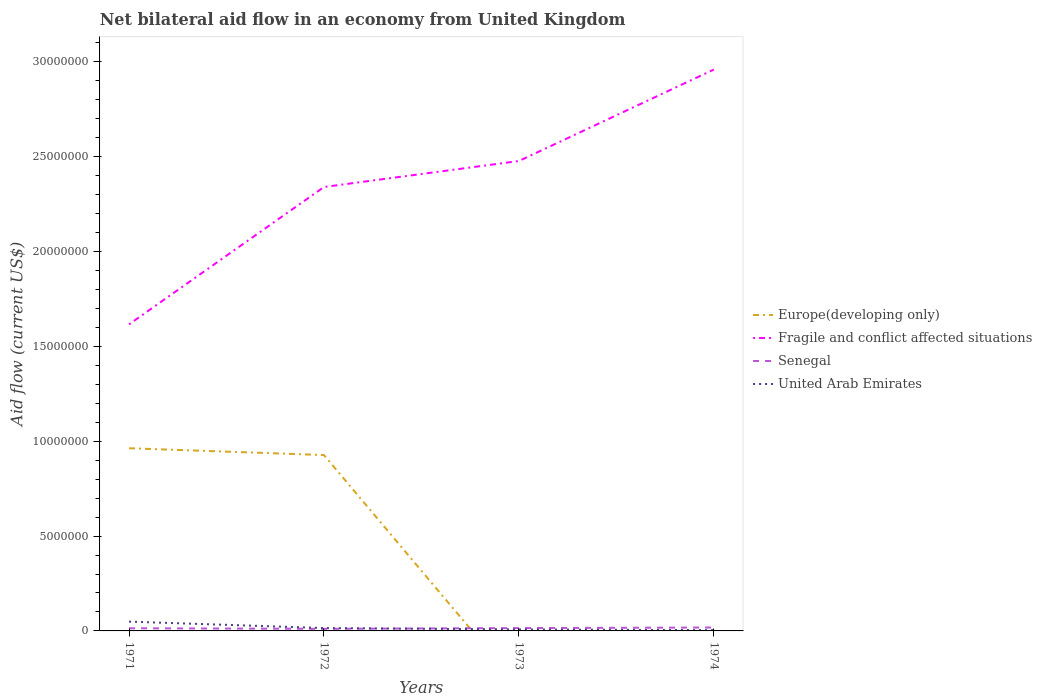How many different coloured lines are there?
Provide a short and direct response. 4. Does the line corresponding to Europe(developing only) intersect with the line corresponding to Senegal?
Provide a succinct answer. Yes. Across all years, what is the maximum net bilateral aid flow in United Arab Emirates?
Make the answer very short. 4.00e+04. What is the total net bilateral aid flow in United Arab Emirates in the graph?
Your answer should be very brief. 4.00e+04. What is the difference between the highest and the second highest net bilateral aid flow in Fragile and conflict affected situations?
Provide a short and direct response. 1.34e+07. What is the difference between the highest and the lowest net bilateral aid flow in United Arab Emirates?
Keep it short and to the point. 1. What is the difference between two consecutive major ticks on the Y-axis?
Offer a very short reply. 5.00e+06. Does the graph contain any zero values?
Make the answer very short. Yes. Does the graph contain grids?
Give a very brief answer. No. Where does the legend appear in the graph?
Your answer should be very brief. Center right. How are the legend labels stacked?
Give a very brief answer. Vertical. What is the title of the graph?
Offer a very short reply. Net bilateral aid flow in an economy from United Kingdom. Does "Iran" appear as one of the legend labels in the graph?
Give a very brief answer. No. What is the label or title of the X-axis?
Your response must be concise. Years. What is the label or title of the Y-axis?
Your response must be concise. Aid flow (current US$). What is the Aid flow (current US$) in Europe(developing only) in 1971?
Your answer should be compact. 9.63e+06. What is the Aid flow (current US$) of Fragile and conflict affected situations in 1971?
Your answer should be very brief. 1.62e+07. What is the Aid flow (current US$) in Europe(developing only) in 1972?
Offer a terse response. 9.27e+06. What is the Aid flow (current US$) in Fragile and conflict affected situations in 1972?
Keep it short and to the point. 2.34e+07. What is the Aid flow (current US$) of Senegal in 1972?
Provide a short and direct response. 1.10e+05. What is the Aid flow (current US$) of United Arab Emirates in 1972?
Give a very brief answer. 1.50e+05. What is the Aid flow (current US$) of Fragile and conflict affected situations in 1973?
Provide a succinct answer. 2.48e+07. What is the Aid flow (current US$) of Fragile and conflict affected situations in 1974?
Your answer should be very brief. 2.96e+07. What is the Aid flow (current US$) in United Arab Emirates in 1974?
Your response must be concise. 4.00e+04. Across all years, what is the maximum Aid flow (current US$) in Europe(developing only)?
Provide a succinct answer. 9.63e+06. Across all years, what is the maximum Aid flow (current US$) of Fragile and conflict affected situations?
Provide a succinct answer. 2.96e+07. Across all years, what is the maximum Aid flow (current US$) of Senegal?
Make the answer very short. 1.80e+05. Across all years, what is the minimum Aid flow (current US$) in Europe(developing only)?
Your response must be concise. 0. Across all years, what is the minimum Aid flow (current US$) in Fragile and conflict affected situations?
Give a very brief answer. 1.62e+07. Across all years, what is the minimum Aid flow (current US$) in United Arab Emirates?
Your response must be concise. 4.00e+04. What is the total Aid flow (current US$) in Europe(developing only) in the graph?
Make the answer very short. 1.89e+07. What is the total Aid flow (current US$) of Fragile and conflict affected situations in the graph?
Provide a short and direct response. 9.39e+07. What is the total Aid flow (current US$) in Senegal in the graph?
Offer a very short reply. 5.80e+05. What is the total Aid flow (current US$) of United Arab Emirates in the graph?
Provide a short and direct response. 7.60e+05. What is the difference between the Aid flow (current US$) in Europe(developing only) in 1971 and that in 1972?
Offer a very short reply. 3.60e+05. What is the difference between the Aid flow (current US$) of Fragile and conflict affected situations in 1971 and that in 1972?
Provide a succinct answer. -7.24e+06. What is the difference between the Aid flow (current US$) of Fragile and conflict affected situations in 1971 and that in 1973?
Your answer should be very brief. -8.61e+06. What is the difference between the Aid flow (current US$) in Senegal in 1971 and that in 1973?
Provide a succinct answer. -10000. What is the difference between the Aid flow (current US$) in Fragile and conflict affected situations in 1971 and that in 1974?
Provide a short and direct response. -1.34e+07. What is the difference between the Aid flow (current US$) of Senegal in 1971 and that in 1974?
Your response must be concise. -4.00e+04. What is the difference between the Aid flow (current US$) of Fragile and conflict affected situations in 1972 and that in 1973?
Ensure brevity in your answer.  -1.37e+06. What is the difference between the Aid flow (current US$) of Senegal in 1972 and that in 1973?
Give a very brief answer. -4.00e+04. What is the difference between the Aid flow (current US$) in Fragile and conflict affected situations in 1972 and that in 1974?
Give a very brief answer. -6.19e+06. What is the difference between the Aid flow (current US$) in Senegal in 1972 and that in 1974?
Provide a succinct answer. -7.00e+04. What is the difference between the Aid flow (current US$) of United Arab Emirates in 1972 and that in 1974?
Ensure brevity in your answer.  1.10e+05. What is the difference between the Aid flow (current US$) of Fragile and conflict affected situations in 1973 and that in 1974?
Provide a succinct answer. -4.82e+06. What is the difference between the Aid flow (current US$) of Senegal in 1973 and that in 1974?
Your response must be concise. -3.00e+04. What is the difference between the Aid flow (current US$) of United Arab Emirates in 1973 and that in 1974?
Make the answer very short. 4.00e+04. What is the difference between the Aid flow (current US$) of Europe(developing only) in 1971 and the Aid flow (current US$) of Fragile and conflict affected situations in 1972?
Ensure brevity in your answer.  -1.38e+07. What is the difference between the Aid flow (current US$) of Europe(developing only) in 1971 and the Aid flow (current US$) of Senegal in 1972?
Make the answer very short. 9.52e+06. What is the difference between the Aid flow (current US$) of Europe(developing only) in 1971 and the Aid flow (current US$) of United Arab Emirates in 1972?
Ensure brevity in your answer.  9.48e+06. What is the difference between the Aid flow (current US$) of Fragile and conflict affected situations in 1971 and the Aid flow (current US$) of Senegal in 1972?
Offer a terse response. 1.60e+07. What is the difference between the Aid flow (current US$) in Fragile and conflict affected situations in 1971 and the Aid flow (current US$) in United Arab Emirates in 1972?
Give a very brief answer. 1.60e+07. What is the difference between the Aid flow (current US$) of Europe(developing only) in 1971 and the Aid flow (current US$) of Fragile and conflict affected situations in 1973?
Provide a short and direct response. -1.51e+07. What is the difference between the Aid flow (current US$) in Europe(developing only) in 1971 and the Aid flow (current US$) in Senegal in 1973?
Offer a very short reply. 9.48e+06. What is the difference between the Aid flow (current US$) of Europe(developing only) in 1971 and the Aid flow (current US$) of United Arab Emirates in 1973?
Your answer should be very brief. 9.55e+06. What is the difference between the Aid flow (current US$) in Fragile and conflict affected situations in 1971 and the Aid flow (current US$) in Senegal in 1973?
Provide a short and direct response. 1.60e+07. What is the difference between the Aid flow (current US$) of Fragile and conflict affected situations in 1971 and the Aid flow (current US$) of United Arab Emirates in 1973?
Your answer should be very brief. 1.61e+07. What is the difference between the Aid flow (current US$) in Europe(developing only) in 1971 and the Aid flow (current US$) in Fragile and conflict affected situations in 1974?
Ensure brevity in your answer.  -2.00e+07. What is the difference between the Aid flow (current US$) in Europe(developing only) in 1971 and the Aid flow (current US$) in Senegal in 1974?
Offer a terse response. 9.45e+06. What is the difference between the Aid flow (current US$) in Europe(developing only) in 1971 and the Aid flow (current US$) in United Arab Emirates in 1974?
Give a very brief answer. 9.59e+06. What is the difference between the Aid flow (current US$) in Fragile and conflict affected situations in 1971 and the Aid flow (current US$) in Senegal in 1974?
Provide a succinct answer. 1.60e+07. What is the difference between the Aid flow (current US$) in Fragile and conflict affected situations in 1971 and the Aid flow (current US$) in United Arab Emirates in 1974?
Your response must be concise. 1.61e+07. What is the difference between the Aid flow (current US$) in Senegal in 1971 and the Aid flow (current US$) in United Arab Emirates in 1974?
Your response must be concise. 1.00e+05. What is the difference between the Aid flow (current US$) in Europe(developing only) in 1972 and the Aid flow (current US$) in Fragile and conflict affected situations in 1973?
Ensure brevity in your answer.  -1.55e+07. What is the difference between the Aid flow (current US$) in Europe(developing only) in 1972 and the Aid flow (current US$) in Senegal in 1973?
Your answer should be very brief. 9.12e+06. What is the difference between the Aid flow (current US$) in Europe(developing only) in 1972 and the Aid flow (current US$) in United Arab Emirates in 1973?
Provide a short and direct response. 9.19e+06. What is the difference between the Aid flow (current US$) in Fragile and conflict affected situations in 1972 and the Aid flow (current US$) in Senegal in 1973?
Make the answer very short. 2.32e+07. What is the difference between the Aid flow (current US$) in Fragile and conflict affected situations in 1972 and the Aid flow (current US$) in United Arab Emirates in 1973?
Offer a terse response. 2.33e+07. What is the difference between the Aid flow (current US$) in Europe(developing only) in 1972 and the Aid flow (current US$) in Fragile and conflict affected situations in 1974?
Your answer should be very brief. -2.03e+07. What is the difference between the Aid flow (current US$) of Europe(developing only) in 1972 and the Aid flow (current US$) of Senegal in 1974?
Offer a terse response. 9.09e+06. What is the difference between the Aid flow (current US$) in Europe(developing only) in 1972 and the Aid flow (current US$) in United Arab Emirates in 1974?
Give a very brief answer. 9.23e+06. What is the difference between the Aid flow (current US$) in Fragile and conflict affected situations in 1972 and the Aid flow (current US$) in Senegal in 1974?
Provide a succinct answer. 2.32e+07. What is the difference between the Aid flow (current US$) in Fragile and conflict affected situations in 1972 and the Aid flow (current US$) in United Arab Emirates in 1974?
Ensure brevity in your answer.  2.34e+07. What is the difference between the Aid flow (current US$) of Fragile and conflict affected situations in 1973 and the Aid flow (current US$) of Senegal in 1974?
Keep it short and to the point. 2.46e+07. What is the difference between the Aid flow (current US$) of Fragile and conflict affected situations in 1973 and the Aid flow (current US$) of United Arab Emirates in 1974?
Keep it short and to the point. 2.47e+07. What is the difference between the Aid flow (current US$) in Senegal in 1973 and the Aid flow (current US$) in United Arab Emirates in 1974?
Your response must be concise. 1.10e+05. What is the average Aid flow (current US$) in Europe(developing only) per year?
Offer a very short reply. 4.72e+06. What is the average Aid flow (current US$) in Fragile and conflict affected situations per year?
Your answer should be compact. 2.35e+07. What is the average Aid flow (current US$) of Senegal per year?
Provide a short and direct response. 1.45e+05. In the year 1971, what is the difference between the Aid flow (current US$) in Europe(developing only) and Aid flow (current US$) in Fragile and conflict affected situations?
Give a very brief answer. -6.53e+06. In the year 1971, what is the difference between the Aid flow (current US$) in Europe(developing only) and Aid flow (current US$) in Senegal?
Make the answer very short. 9.49e+06. In the year 1971, what is the difference between the Aid flow (current US$) in Europe(developing only) and Aid flow (current US$) in United Arab Emirates?
Make the answer very short. 9.14e+06. In the year 1971, what is the difference between the Aid flow (current US$) in Fragile and conflict affected situations and Aid flow (current US$) in Senegal?
Offer a terse response. 1.60e+07. In the year 1971, what is the difference between the Aid flow (current US$) of Fragile and conflict affected situations and Aid flow (current US$) of United Arab Emirates?
Your answer should be very brief. 1.57e+07. In the year 1971, what is the difference between the Aid flow (current US$) of Senegal and Aid flow (current US$) of United Arab Emirates?
Your answer should be compact. -3.50e+05. In the year 1972, what is the difference between the Aid flow (current US$) of Europe(developing only) and Aid flow (current US$) of Fragile and conflict affected situations?
Your answer should be very brief. -1.41e+07. In the year 1972, what is the difference between the Aid flow (current US$) of Europe(developing only) and Aid flow (current US$) of Senegal?
Your answer should be very brief. 9.16e+06. In the year 1972, what is the difference between the Aid flow (current US$) in Europe(developing only) and Aid flow (current US$) in United Arab Emirates?
Make the answer very short. 9.12e+06. In the year 1972, what is the difference between the Aid flow (current US$) of Fragile and conflict affected situations and Aid flow (current US$) of Senegal?
Your answer should be compact. 2.33e+07. In the year 1972, what is the difference between the Aid flow (current US$) in Fragile and conflict affected situations and Aid flow (current US$) in United Arab Emirates?
Give a very brief answer. 2.32e+07. In the year 1973, what is the difference between the Aid flow (current US$) in Fragile and conflict affected situations and Aid flow (current US$) in Senegal?
Offer a very short reply. 2.46e+07. In the year 1973, what is the difference between the Aid flow (current US$) in Fragile and conflict affected situations and Aid flow (current US$) in United Arab Emirates?
Give a very brief answer. 2.47e+07. In the year 1974, what is the difference between the Aid flow (current US$) of Fragile and conflict affected situations and Aid flow (current US$) of Senegal?
Provide a succinct answer. 2.94e+07. In the year 1974, what is the difference between the Aid flow (current US$) of Fragile and conflict affected situations and Aid flow (current US$) of United Arab Emirates?
Give a very brief answer. 2.96e+07. In the year 1974, what is the difference between the Aid flow (current US$) in Senegal and Aid flow (current US$) in United Arab Emirates?
Provide a short and direct response. 1.40e+05. What is the ratio of the Aid flow (current US$) of Europe(developing only) in 1971 to that in 1972?
Offer a terse response. 1.04. What is the ratio of the Aid flow (current US$) of Fragile and conflict affected situations in 1971 to that in 1972?
Your answer should be compact. 0.69. What is the ratio of the Aid flow (current US$) of Senegal in 1971 to that in 1972?
Keep it short and to the point. 1.27. What is the ratio of the Aid flow (current US$) of United Arab Emirates in 1971 to that in 1972?
Provide a short and direct response. 3.27. What is the ratio of the Aid flow (current US$) in Fragile and conflict affected situations in 1971 to that in 1973?
Provide a succinct answer. 0.65. What is the ratio of the Aid flow (current US$) in United Arab Emirates in 1971 to that in 1973?
Make the answer very short. 6.12. What is the ratio of the Aid flow (current US$) of Fragile and conflict affected situations in 1971 to that in 1974?
Offer a very short reply. 0.55. What is the ratio of the Aid flow (current US$) in United Arab Emirates in 1971 to that in 1974?
Make the answer very short. 12.25. What is the ratio of the Aid flow (current US$) in Fragile and conflict affected situations in 1972 to that in 1973?
Provide a short and direct response. 0.94. What is the ratio of the Aid flow (current US$) of Senegal in 1972 to that in 1973?
Offer a terse response. 0.73. What is the ratio of the Aid flow (current US$) in United Arab Emirates in 1972 to that in 1973?
Ensure brevity in your answer.  1.88. What is the ratio of the Aid flow (current US$) in Fragile and conflict affected situations in 1972 to that in 1974?
Ensure brevity in your answer.  0.79. What is the ratio of the Aid flow (current US$) of Senegal in 1972 to that in 1974?
Ensure brevity in your answer.  0.61. What is the ratio of the Aid flow (current US$) of United Arab Emirates in 1972 to that in 1974?
Offer a very short reply. 3.75. What is the ratio of the Aid flow (current US$) in Fragile and conflict affected situations in 1973 to that in 1974?
Provide a succinct answer. 0.84. What is the difference between the highest and the second highest Aid flow (current US$) in Fragile and conflict affected situations?
Provide a succinct answer. 4.82e+06. What is the difference between the highest and the second highest Aid flow (current US$) of Senegal?
Your answer should be compact. 3.00e+04. What is the difference between the highest and the lowest Aid flow (current US$) of Europe(developing only)?
Give a very brief answer. 9.63e+06. What is the difference between the highest and the lowest Aid flow (current US$) in Fragile and conflict affected situations?
Your answer should be very brief. 1.34e+07. What is the difference between the highest and the lowest Aid flow (current US$) in Senegal?
Offer a terse response. 7.00e+04. What is the difference between the highest and the lowest Aid flow (current US$) of United Arab Emirates?
Give a very brief answer. 4.50e+05. 